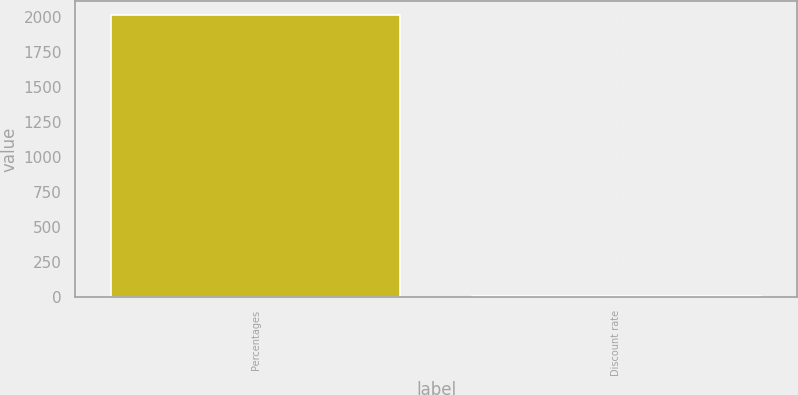<chart> <loc_0><loc_0><loc_500><loc_500><bar_chart><fcel>Percentages<fcel>Discount rate<nl><fcel>2015<fcel>3.94<nl></chart> 